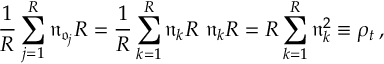Convert formula to latex. <formula><loc_0><loc_0><loc_500><loc_500>\frac { 1 } { R } \sum _ { j = 1 } ^ { R } \mathfrak { n } _ { \mathfrak { o } _ { j } } R = \frac { 1 } { R } \sum _ { k = 1 } ^ { R } \mathfrak { n } _ { k } R \mathfrak { n } _ { k } R = R \sum _ { k = 1 } ^ { R } \mathfrak { n } _ { k } ^ { 2 } \equiv \rho _ { t } \, ,</formula> 